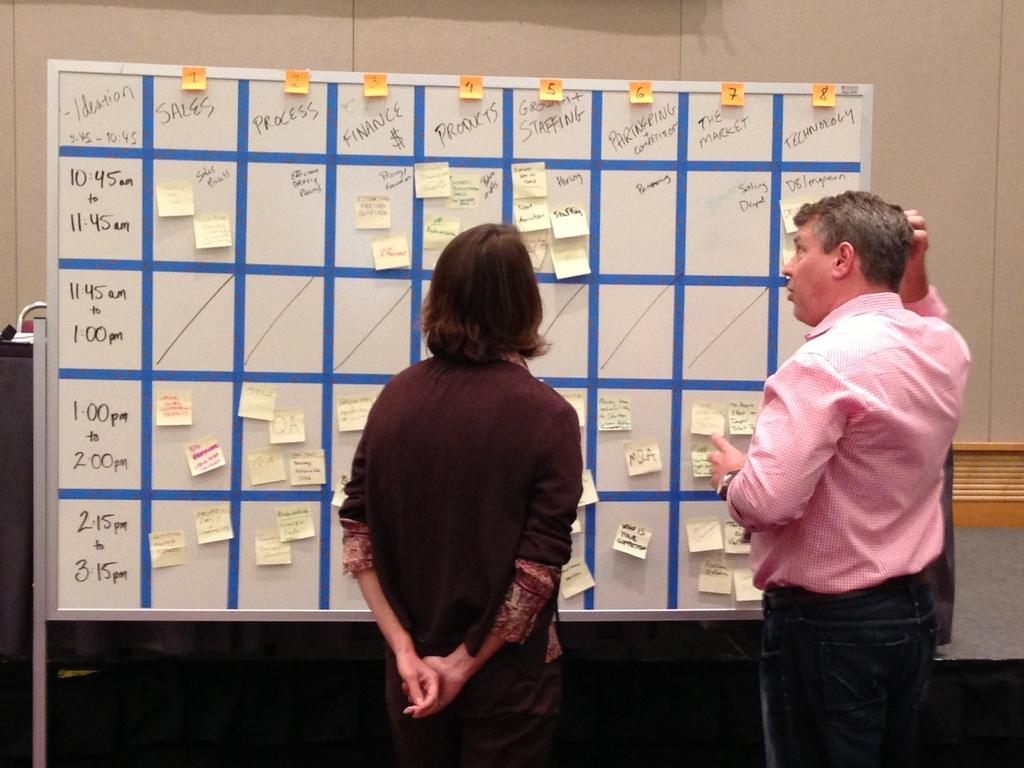How many people are present in the image? There are two people standing on a path in the image. What are the people doing in the image? The people are standing in front of a whiteboard with papers. What is located behind the whiteboard? There is a wall behind the whiteboard. What type of cloth is draped over the woman in the image? There is no woman or cloth present in the image; it features two people standing on a path with a whiteboard and papers. 